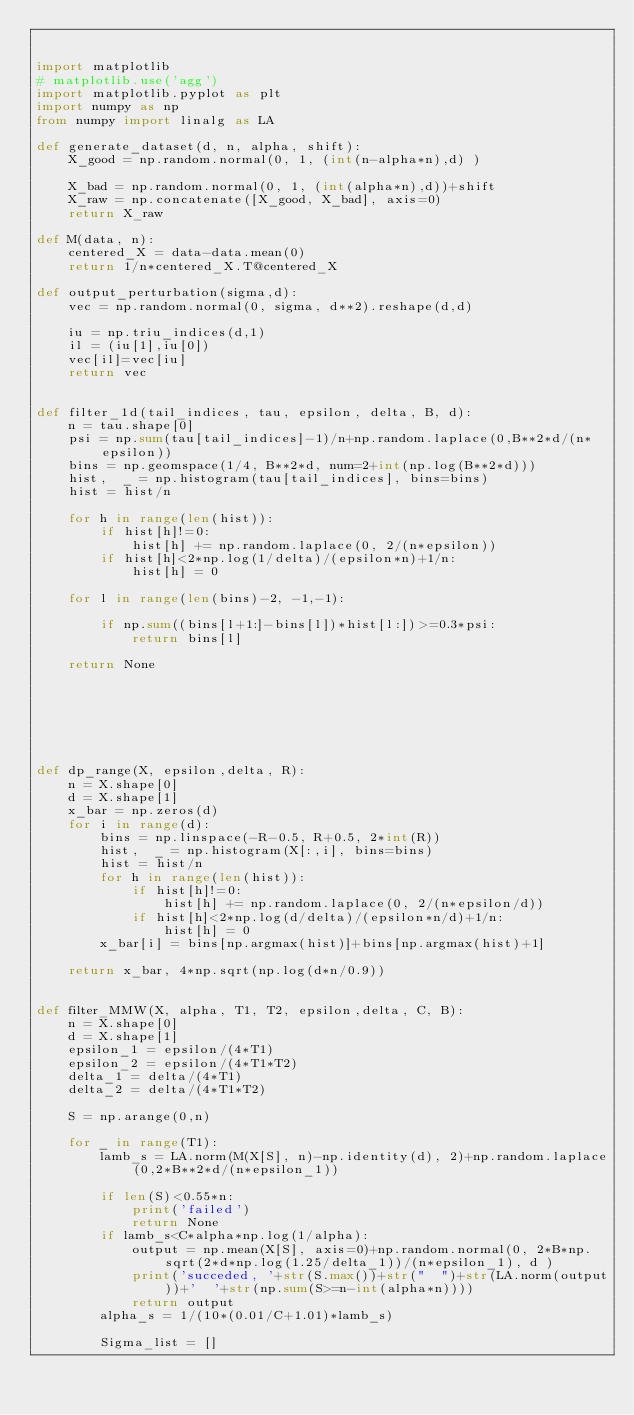<code> <loc_0><loc_0><loc_500><loc_500><_Python_>

import matplotlib
# matplotlib.use('agg')
import matplotlib.pyplot as plt
import numpy as np
from numpy import linalg as LA

def generate_dataset(d, n, alpha, shift):
    X_good = np.random.normal(0, 1, (int(n-alpha*n),d) )

    X_bad = np.random.normal(0, 1, (int(alpha*n),d))+shift
    X_raw = np.concatenate([X_good, X_bad], axis=0)
    return X_raw

def M(data, n):
    centered_X = data-data.mean(0)
    return 1/n*centered_X.T@centered_X

def output_perturbation(sigma,d):
    vec = np.random.normal(0, sigma, d**2).reshape(d,d)
    
    iu = np.triu_indices(d,1)
    il = (iu[1],iu[0])
    vec[il]=vec[iu]
    return vec


def filter_1d(tail_indices, tau, epsilon, delta, B, d):
    n = tau.shape[0]
    psi = np.sum(tau[tail_indices]-1)/n+np.random.laplace(0,B**2*d/(n*epsilon))
    bins = np.geomspace(1/4, B**2*d, num=2+int(np.log(B**2*d)))
    hist,  _ = np.histogram(tau[tail_indices], bins=bins)
    hist = hist/n
    
    for h in range(len(hist)):
        if hist[h]!=0:
            hist[h] += np.random.laplace(0, 2/(n*epsilon))
        if hist[h]<2*np.log(1/delta)/(epsilon*n)+1/n:
            hist[h] = 0

    for l in range(len(bins)-2, -1,-1):

        if np.sum((bins[l+1:]-bins[l])*hist[l:])>=0.3*psi:
            return bins[l]
    
    return None





        
        
def dp_range(X, epsilon,delta, R):
    n = X.shape[0]
    d = X.shape[1]
    x_bar = np.zeros(d)
    for i in range(d):
        bins = np.linspace(-R-0.5, R+0.5, 2*int(R))
        hist,  _ = np.histogram(X[:,i], bins=bins)
        hist = hist/n
        for h in range(len(hist)):
            if hist[h]!=0:
                hist[h] += np.random.laplace(0, 2/(n*epsilon/d))
            if hist[h]<2*np.log(d/delta)/(epsilon*n/d)+1/n:
                hist[h] = 0
        x_bar[i] = bins[np.argmax(hist)]+bins[np.argmax(hist)+1]
                
    return x_bar, 4*np.sqrt(np.log(d*n/0.9))


def filter_MMW(X, alpha, T1, T2, epsilon,delta, C, B):
    n = X.shape[0]
    d = X.shape[1]
    epsilon_1 = epsilon/(4*T1)
    epsilon_2 = epsilon/(4*T1*T2)
    delta_1 = delta/(4*T1)
    delta_2 = delta/(4*T1*T2)
    
    S = np.arange(0,n)
    
    for _ in range(T1):
        lamb_s = LA.norm(M(X[S], n)-np.identity(d), 2)+np.random.laplace(0,2*B**2*d/(n*epsilon_1))
        
        if len(S)<0.55*n:
            print('failed')
            return None
        if lamb_s<C*alpha*np.log(1/alpha):
            output = np.mean(X[S], axis=0)+np.random.normal(0, 2*B*np.sqrt(2*d*np.log(1.25/delta_1))/(n*epsilon_1), d )
            print('succeded, '+str(S.max())+str("  ")+str(LA.norm(output))+'  '+str(np.sum(S>=n-int(alpha*n))))
            return output
        alpha_s = 1/(10*(0.01/C+1.01)*lamb_s)

        Sigma_list = []</code> 